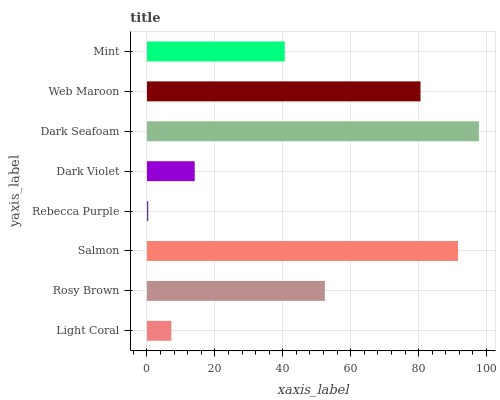Is Rebecca Purple the minimum?
Answer yes or no. Yes. Is Dark Seafoam the maximum?
Answer yes or no. Yes. Is Rosy Brown the minimum?
Answer yes or no. No. Is Rosy Brown the maximum?
Answer yes or no. No. Is Rosy Brown greater than Light Coral?
Answer yes or no. Yes. Is Light Coral less than Rosy Brown?
Answer yes or no. Yes. Is Light Coral greater than Rosy Brown?
Answer yes or no. No. Is Rosy Brown less than Light Coral?
Answer yes or no. No. Is Rosy Brown the high median?
Answer yes or no. Yes. Is Mint the low median?
Answer yes or no. Yes. Is Web Maroon the high median?
Answer yes or no. No. Is Light Coral the low median?
Answer yes or no. No. 